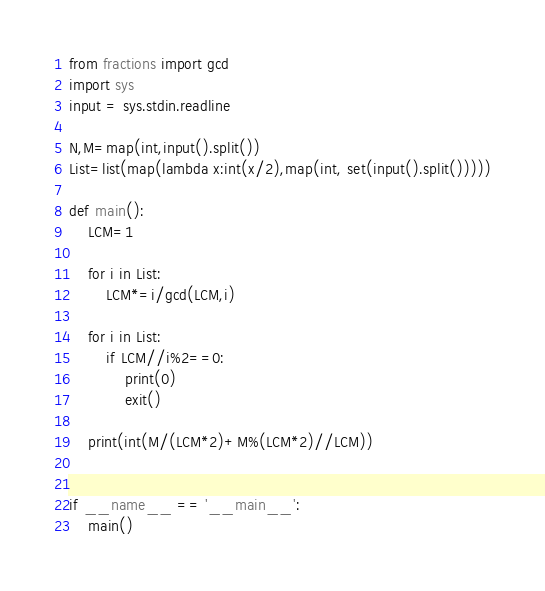Convert code to text. <code><loc_0><loc_0><loc_500><loc_500><_Python_>from fractions import gcd
import sys
input = sys.stdin.readline

N,M=map(int,input().split())
List=list(map(lambda x:int(x/2),map(int, set(input().split()))))

def main():
    LCM=1

    for i in List:
        LCM*=i/gcd(LCM,i)

    for i in List:
        if LCM//i%2==0:
            print(0)
            exit()

    print(int(M/(LCM*2)+M%(LCM*2)//LCM))


if __name__ == '__main__':
    main()
</code> 